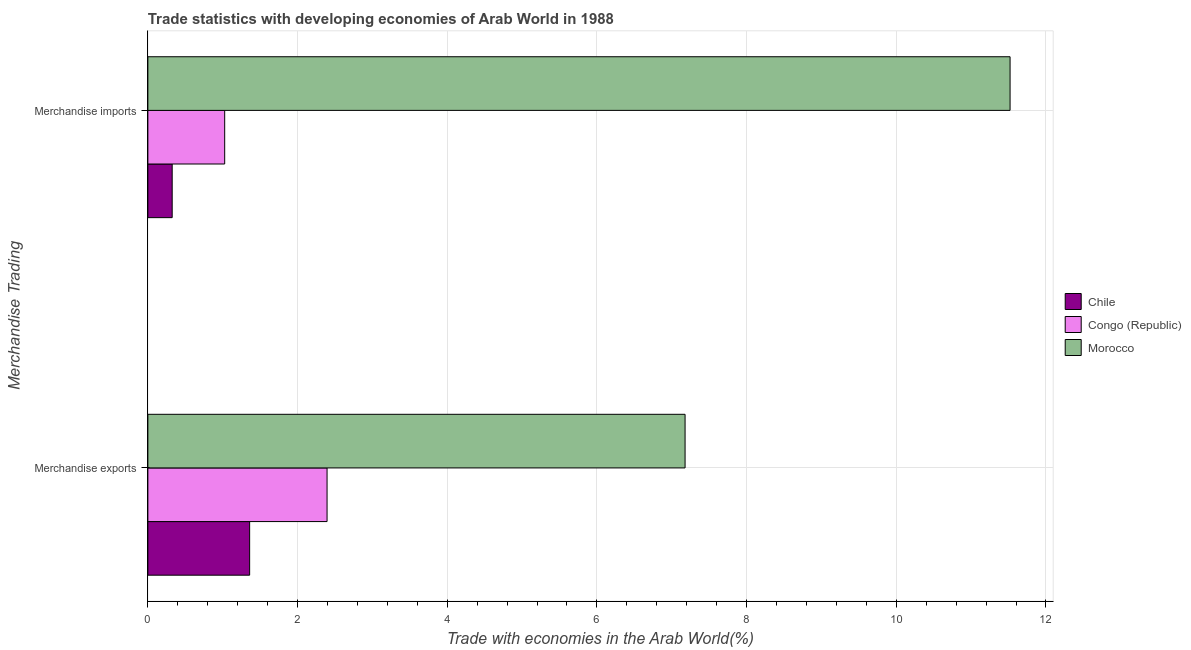How many different coloured bars are there?
Offer a terse response. 3. Are the number of bars on each tick of the Y-axis equal?
Offer a very short reply. Yes. What is the label of the 1st group of bars from the top?
Provide a short and direct response. Merchandise imports. What is the merchandise exports in Morocco?
Offer a very short reply. 7.18. Across all countries, what is the maximum merchandise imports?
Provide a succinct answer. 11.52. Across all countries, what is the minimum merchandise imports?
Make the answer very short. 0.32. In which country was the merchandise imports maximum?
Give a very brief answer. Morocco. In which country was the merchandise exports minimum?
Offer a terse response. Chile. What is the total merchandise exports in the graph?
Give a very brief answer. 10.93. What is the difference between the merchandise imports in Morocco and that in Chile?
Give a very brief answer. 11.2. What is the difference between the merchandise exports in Morocco and the merchandise imports in Chile?
Keep it short and to the point. 6.85. What is the average merchandise exports per country?
Provide a short and direct response. 3.64. What is the difference between the merchandise imports and merchandise exports in Morocco?
Provide a succinct answer. 4.34. In how many countries, is the merchandise imports greater than 6.8 %?
Ensure brevity in your answer.  1. What is the ratio of the merchandise imports in Congo (Republic) to that in Chile?
Your response must be concise. 3.16. In how many countries, is the merchandise imports greater than the average merchandise imports taken over all countries?
Ensure brevity in your answer.  1. What does the 1st bar from the top in Merchandise imports represents?
Keep it short and to the point. Morocco. What does the 1st bar from the bottom in Merchandise exports represents?
Offer a terse response. Chile. Does the graph contain any zero values?
Your answer should be very brief. No. Does the graph contain grids?
Provide a succinct answer. Yes. How many legend labels are there?
Your response must be concise. 3. What is the title of the graph?
Offer a terse response. Trade statistics with developing economies of Arab World in 1988. Does "Russian Federation" appear as one of the legend labels in the graph?
Provide a succinct answer. No. What is the label or title of the X-axis?
Give a very brief answer. Trade with economies in the Arab World(%). What is the label or title of the Y-axis?
Ensure brevity in your answer.  Merchandise Trading. What is the Trade with economies in the Arab World(%) of Chile in Merchandise exports?
Your answer should be compact. 1.36. What is the Trade with economies in the Arab World(%) in Congo (Republic) in Merchandise exports?
Ensure brevity in your answer.  2.39. What is the Trade with economies in the Arab World(%) of Morocco in Merchandise exports?
Offer a terse response. 7.18. What is the Trade with economies in the Arab World(%) of Chile in Merchandise imports?
Offer a very short reply. 0.32. What is the Trade with economies in the Arab World(%) in Congo (Republic) in Merchandise imports?
Ensure brevity in your answer.  1.03. What is the Trade with economies in the Arab World(%) of Morocco in Merchandise imports?
Offer a terse response. 11.52. Across all Merchandise Trading, what is the maximum Trade with economies in the Arab World(%) of Chile?
Make the answer very short. 1.36. Across all Merchandise Trading, what is the maximum Trade with economies in the Arab World(%) of Congo (Republic)?
Give a very brief answer. 2.39. Across all Merchandise Trading, what is the maximum Trade with economies in the Arab World(%) of Morocco?
Your answer should be very brief. 11.52. Across all Merchandise Trading, what is the minimum Trade with economies in the Arab World(%) in Chile?
Make the answer very short. 0.32. Across all Merchandise Trading, what is the minimum Trade with economies in the Arab World(%) in Congo (Republic)?
Keep it short and to the point. 1.03. Across all Merchandise Trading, what is the minimum Trade with economies in the Arab World(%) in Morocco?
Give a very brief answer. 7.18. What is the total Trade with economies in the Arab World(%) in Chile in the graph?
Ensure brevity in your answer.  1.68. What is the total Trade with economies in the Arab World(%) of Congo (Republic) in the graph?
Your answer should be very brief. 3.42. What is the total Trade with economies in the Arab World(%) of Morocco in the graph?
Your response must be concise. 18.7. What is the difference between the Trade with economies in the Arab World(%) in Chile in Merchandise exports and that in Merchandise imports?
Make the answer very short. 1.03. What is the difference between the Trade with economies in the Arab World(%) in Congo (Republic) in Merchandise exports and that in Merchandise imports?
Offer a very short reply. 1.37. What is the difference between the Trade with economies in the Arab World(%) of Morocco in Merchandise exports and that in Merchandise imports?
Keep it short and to the point. -4.34. What is the difference between the Trade with economies in the Arab World(%) of Chile in Merchandise exports and the Trade with economies in the Arab World(%) of Congo (Republic) in Merchandise imports?
Offer a terse response. 0.33. What is the difference between the Trade with economies in the Arab World(%) of Chile in Merchandise exports and the Trade with economies in the Arab World(%) of Morocco in Merchandise imports?
Your answer should be compact. -10.16. What is the difference between the Trade with economies in the Arab World(%) of Congo (Republic) in Merchandise exports and the Trade with economies in the Arab World(%) of Morocco in Merchandise imports?
Make the answer very short. -9.13. What is the average Trade with economies in the Arab World(%) of Chile per Merchandise Trading?
Make the answer very short. 0.84. What is the average Trade with economies in the Arab World(%) of Congo (Republic) per Merchandise Trading?
Make the answer very short. 1.71. What is the average Trade with economies in the Arab World(%) of Morocco per Merchandise Trading?
Keep it short and to the point. 9.35. What is the difference between the Trade with economies in the Arab World(%) of Chile and Trade with economies in the Arab World(%) of Congo (Republic) in Merchandise exports?
Ensure brevity in your answer.  -1.03. What is the difference between the Trade with economies in the Arab World(%) in Chile and Trade with economies in the Arab World(%) in Morocco in Merchandise exports?
Offer a very short reply. -5.82. What is the difference between the Trade with economies in the Arab World(%) in Congo (Republic) and Trade with economies in the Arab World(%) in Morocco in Merchandise exports?
Provide a succinct answer. -4.78. What is the difference between the Trade with economies in the Arab World(%) in Chile and Trade with economies in the Arab World(%) in Congo (Republic) in Merchandise imports?
Give a very brief answer. -0.7. What is the difference between the Trade with economies in the Arab World(%) of Chile and Trade with economies in the Arab World(%) of Morocco in Merchandise imports?
Offer a very short reply. -11.2. What is the difference between the Trade with economies in the Arab World(%) of Congo (Republic) and Trade with economies in the Arab World(%) of Morocco in Merchandise imports?
Offer a very short reply. -10.49. What is the ratio of the Trade with economies in the Arab World(%) of Chile in Merchandise exports to that in Merchandise imports?
Offer a very short reply. 4.18. What is the ratio of the Trade with economies in the Arab World(%) in Congo (Republic) in Merchandise exports to that in Merchandise imports?
Your answer should be very brief. 2.33. What is the ratio of the Trade with economies in the Arab World(%) of Morocco in Merchandise exports to that in Merchandise imports?
Ensure brevity in your answer.  0.62. What is the difference between the highest and the second highest Trade with economies in the Arab World(%) in Chile?
Keep it short and to the point. 1.03. What is the difference between the highest and the second highest Trade with economies in the Arab World(%) of Congo (Republic)?
Your answer should be very brief. 1.37. What is the difference between the highest and the second highest Trade with economies in the Arab World(%) in Morocco?
Your answer should be very brief. 4.34. What is the difference between the highest and the lowest Trade with economies in the Arab World(%) in Chile?
Your answer should be very brief. 1.03. What is the difference between the highest and the lowest Trade with economies in the Arab World(%) of Congo (Republic)?
Provide a short and direct response. 1.37. What is the difference between the highest and the lowest Trade with economies in the Arab World(%) in Morocco?
Your answer should be compact. 4.34. 